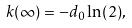Convert formula to latex. <formula><loc_0><loc_0><loc_500><loc_500>k ( \infty ) = - d _ { 0 } \ln ( 2 ) ,</formula> 